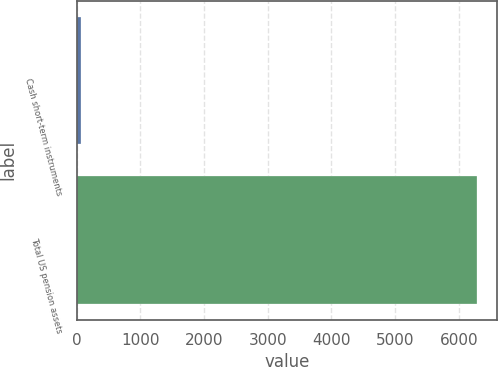<chart> <loc_0><loc_0><loc_500><loc_500><bar_chart><fcel>Cash short-term instruments<fcel>Total US pension assets<nl><fcel>74<fcel>6290<nl></chart> 